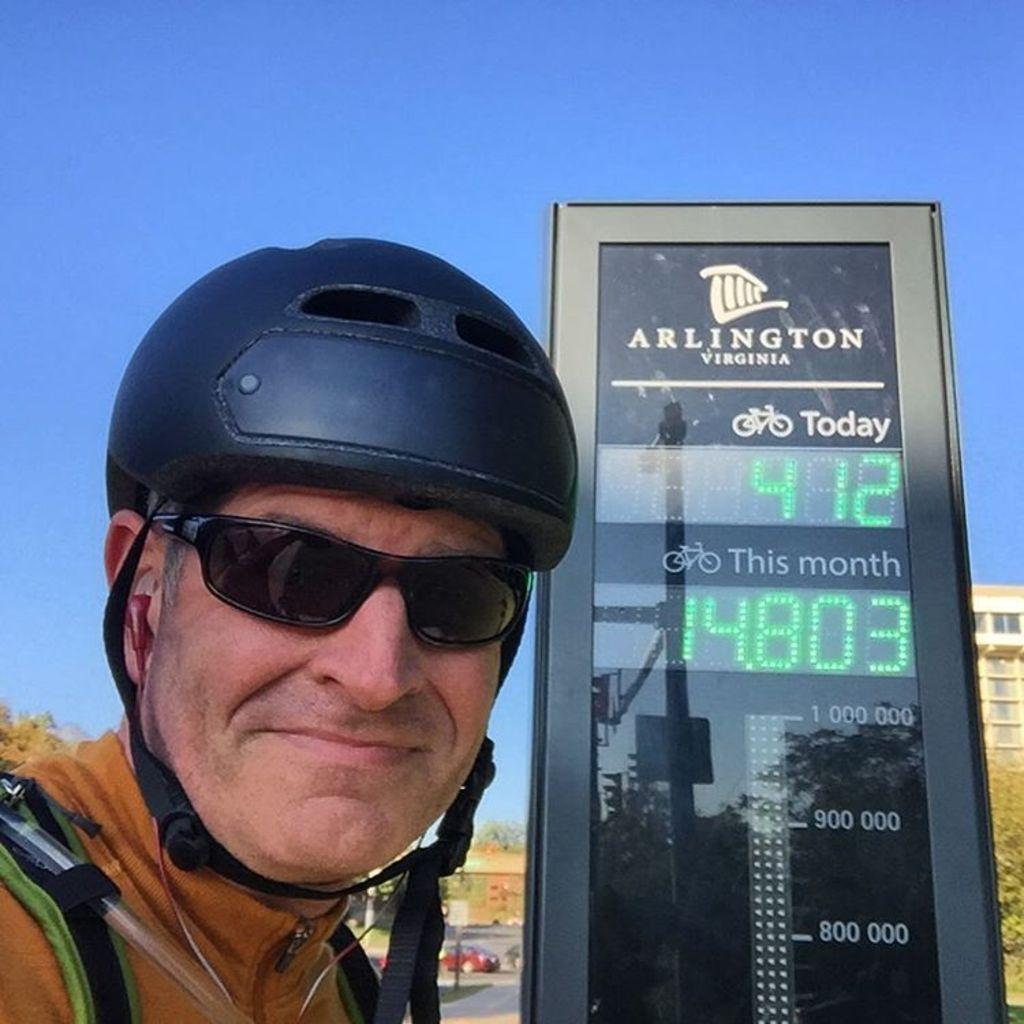Who is present in the image? There is a man in the image. What protective gear is the man wearing? The man is wearing a helmet and goggles. What can be seen in the background of the image? There are buildings, trees, a vehicle, and the sky visible in the background of the image. What type of baby is being discussed in the image? There is no baby or discussion present in the image. Can you see any ants in the image? There are no ants visible in the image. 